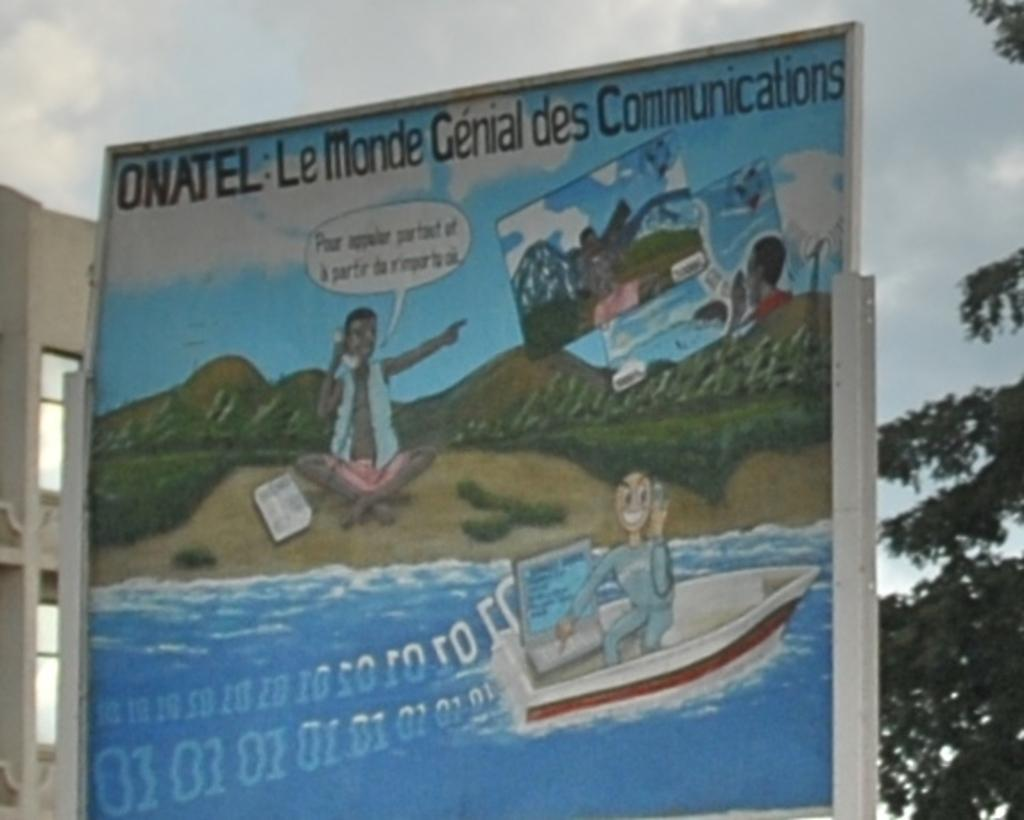<image>
Provide a brief description of the given image. A cartoon style billboard says ONATEL on the top section of it. 